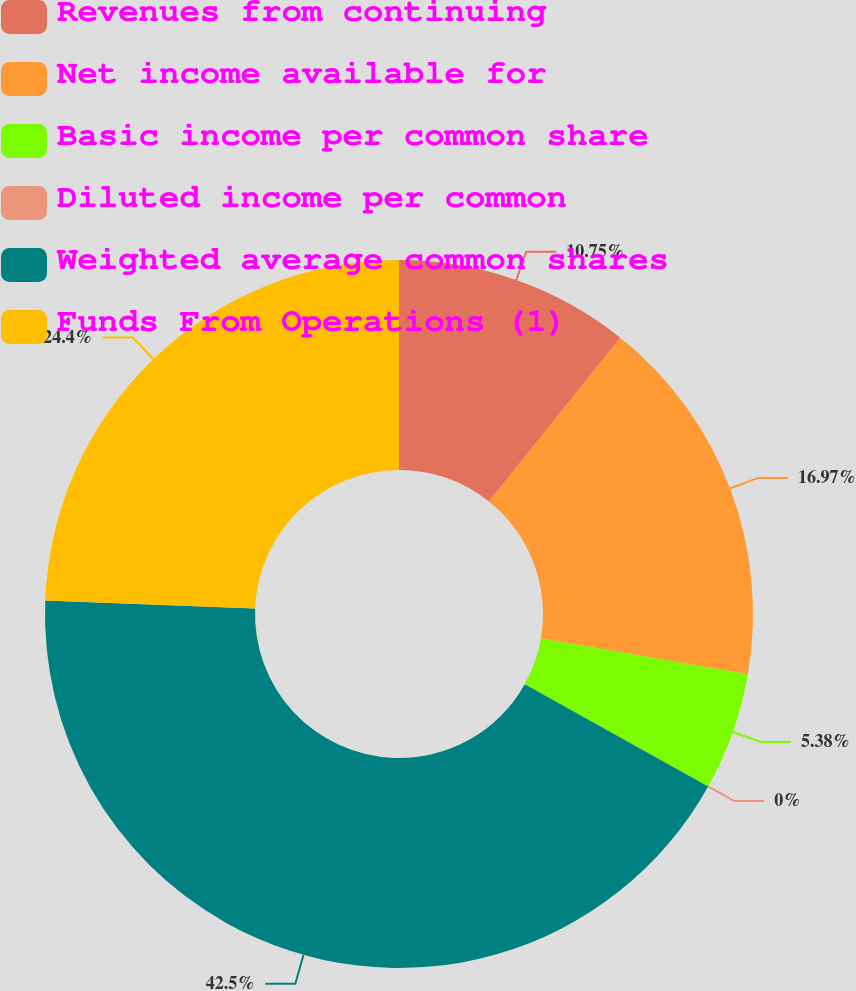<chart> <loc_0><loc_0><loc_500><loc_500><pie_chart><fcel>Revenues from continuing<fcel>Net income available for<fcel>Basic income per common share<fcel>Diluted income per common<fcel>Weighted average common shares<fcel>Funds From Operations (1)<nl><fcel>10.75%<fcel>16.97%<fcel>5.38%<fcel>0.0%<fcel>42.51%<fcel>24.4%<nl></chart> 